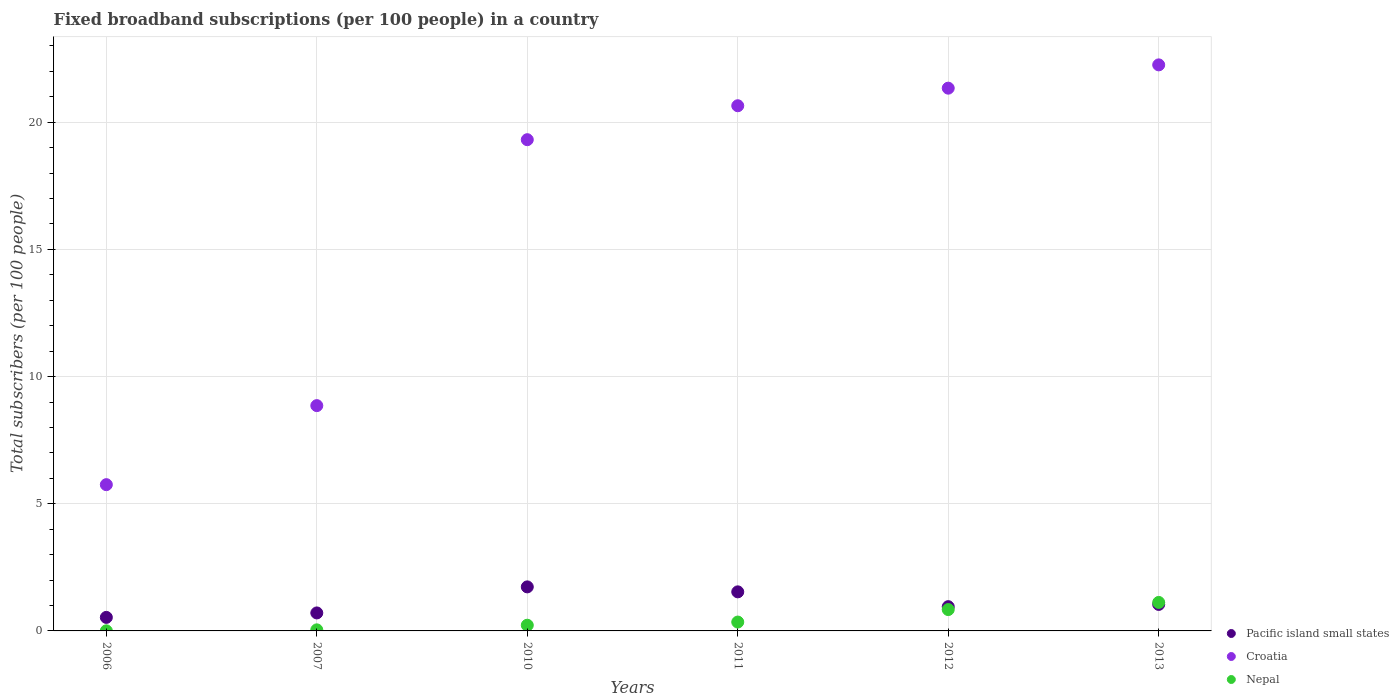How many different coloured dotlines are there?
Keep it short and to the point. 3. Is the number of dotlines equal to the number of legend labels?
Offer a very short reply. Yes. What is the number of broadband subscriptions in Nepal in 2007?
Offer a very short reply. 0.04. Across all years, what is the maximum number of broadband subscriptions in Pacific island small states?
Keep it short and to the point. 1.73. Across all years, what is the minimum number of broadband subscriptions in Nepal?
Your answer should be very brief. 0. In which year was the number of broadband subscriptions in Nepal minimum?
Ensure brevity in your answer.  2006. What is the total number of broadband subscriptions in Pacific island small states in the graph?
Provide a succinct answer. 6.5. What is the difference between the number of broadband subscriptions in Nepal in 2007 and that in 2011?
Provide a short and direct response. -0.31. What is the difference between the number of broadband subscriptions in Croatia in 2013 and the number of broadband subscriptions in Pacific island small states in 2007?
Give a very brief answer. 21.55. What is the average number of broadband subscriptions in Pacific island small states per year?
Offer a terse response. 1.08. In the year 2011, what is the difference between the number of broadband subscriptions in Pacific island small states and number of broadband subscriptions in Nepal?
Provide a short and direct response. 1.19. In how many years, is the number of broadband subscriptions in Croatia greater than 6?
Make the answer very short. 5. What is the ratio of the number of broadband subscriptions in Croatia in 2007 to that in 2010?
Offer a terse response. 0.46. Is the number of broadband subscriptions in Nepal in 2011 less than that in 2013?
Ensure brevity in your answer.  Yes. Is the difference between the number of broadband subscriptions in Pacific island small states in 2007 and 2011 greater than the difference between the number of broadband subscriptions in Nepal in 2007 and 2011?
Offer a very short reply. No. What is the difference between the highest and the second highest number of broadband subscriptions in Croatia?
Ensure brevity in your answer.  0.92. What is the difference between the highest and the lowest number of broadband subscriptions in Croatia?
Offer a very short reply. 16.51. Is it the case that in every year, the sum of the number of broadband subscriptions in Pacific island small states and number of broadband subscriptions in Nepal  is greater than the number of broadband subscriptions in Croatia?
Your response must be concise. No. Does the number of broadband subscriptions in Nepal monotonically increase over the years?
Your answer should be compact. Yes. Is the number of broadband subscriptions in Pacific island small states strictly less than the number of broadband subscriptions in Croatia over the years?
Your answer should be very brief. Yes. What is the difference between two consecutive major ticks on the Y-axis?
Provide a short and direct response. 5. Are the values on the major ticks of Y-axis written in scientific E-notation?
Offer a terse response. No. Does the graph contain any zero values?
Make the answer very short. No. Where does the legend appear in the graph?
Your answer should be very brief. Bottom right. How many legend labels are there?
Your answer should be compact. 3. How are the legend labels stacked?
Your answer should be compact. Vertical. What is the title of the graph?
Your answer should be very brief. Fixed broadband subscriptions (per 100 people) in a country. What is the label or title of the X-axis?
Provide a succinct answer. Years. What is the label or title of the Y-axis?
Your answer should be very brief. Total subscribers (per 100 people). What is the Total subscribers (per 100 people) of Pacific island small states in 2006?
Offer a very short reply. 0.53. What is the Total subscribers (per 100 people) of Croatia in 2006?
Make the answer very short. 5.75. What is the Total subscribers (per 100 people) of Nepal in 2006?
Keep it short and to the point. 0. What is the Total subscribers (per 100 people) in Pacific island small states in 2007?
Your answer should be compact. 0.71. What is the Total subscribers (per 100 people) in Croatia in 2007?
Keep it short and to the point. 8.86. What is the Total subscribers (per 100 people) in Nepal in 2007?
Your answer should be very brief. 0.04. What is the Total subscribers (per 100 people) of Pacific island small states in 2010?
Offer a very short reply. 1.73. What is the Total subscribers (per 100 people) of Croatia in 2010?
Give a very brief answer. 19.31. What is the Total subscribers (per 100 people) in Nepal in 2010?
Your answer should be compact. 0.22. What is the Total subscribers (per 100 people) in Pacific island small states in 2011?
Give a very brief answer. 1.54. What is the Total subscribers (per 100 people) of Croatia in 2011?
Provide a short and direct response. 20.65. What is the Total subscribers (per 100 people) in Nepal in 2011?
Offer a very short reply. 0.35. What is the Total subscribers (per 100 people) in Pacific island small states in 2012?
Your answer should be very brief. 0.95. What is the Total subscribers (per 100 people) of Croatia in 2012?
Ensure brevity in your answer.  21.34. What is the Total subscribers (per 100 people) of Nepal in 2012?
Provide a short and direct response. 0.84. What is the Total subscribers (per 100 people) in Pacific island small states in 2013?
Ensure brevity in your answer.  1.04. What is the Total subscribers (per 100 people) of Croatia in 2013?
Ensure brevity in your answer.  22.26. What is the Total subscribers (per 100 people) of Nepal in 2013?
Offer a terse response. 1.12. Across all years, what is the maximum Total subscribers (per 100 people) in Pacific island small states?
Provide a succinct answer. 1.73. Across all years, what is the maximum Total subscribers (per 100 people) of Croatia?
Keep it short and to the point. 22.26. Across all years, what is the maximum Total subscribers (per 100 people) of Nepal?
Provide a short and direct response. 1.12. Across all years, what is the minimum Total subscribers (per 100 people) of Pacific island small states?
Ensure brevity in your answer.  0.53. Across all years, what is the minimum Total subscribers (per 100 people) in Croatia?
Offer a very short reply. 5.75. Across all years, what is the minimum Total subscribers (per 100 people) in Nepal?
Make the answer very short. 0. What is the total Total subscribers (per 100 people) of Pacific island small states in the graph?
Keep it short and to the point. 6.5. What is the total Total subscribers (per 100 people) in Croatia in the graph?
Offer a very short reply. 98.17. What is the total Total subscribers (per 100 people) of Nepal in the graph?
Offer a very short reply. 2.58. What is the difference between the Total subscribers (per 100 people) of Pacific island small states in 2006 and that in 2007?
Provide a succinct answer. -0.18. What is the difference between the Total subscribers (per 100 people) of Croatia in 2006 and that in 2007?
Your response must be concise. -3.11. What is the difference between the Total subscribers (per 100 people) in Nepal in 2006 and that in 2007?
Ensure brevity in your answer.  -0.04. What is the difference between the Total subscribers (per 100 people) of Pacific island small states in 2006 and that in 2010?
Offer a terse response. -1.2. What is the difference between the Total subscribers (per 100 people) in Croatia in 2006 and that in 2010?
Provide a short and direct response. -13.56. What is the difference between the Total subscribers (per 100 people) in Nepal in 2006 and that in 2010?
Ensure brevity in your answer.  -0.22. What is the difference between the Total subscribers (per 100 people) of Pacific island small states in 2006 and that in 2011?
Offer a very short reply. -1. What is the difference between the Total subscribers (per 100 people) in Croatia in 2006 and that in 2011?
Provide a short and direct response. -14.9. What is the difference between the Total subscribers (per 100 people) of Nepal in 2006 and that in 2011?
Provide a succinct answer. -0.34. What is the difference between the Total subscribers (per 100 people) of Pacific island small states in 2006 and that in 2012?
Your answer should be compact. -0.42. What is the difference between the Total subscribers (per 100 people) in Croatia in 2006 and that in 2012?
Give a very brief answer. -15.59. What is the difference between the Total subscribers (per 100 people) in Nepal in 2006 and that in 2012?
Your answer should be compact. -0.84. What is the difference between the Total subscribers (per 100 people) of Pacific island small states in 2006 and that in 2013?
Keep it short and to the point. -0.51. What is the difference between the Total subscribers (per 100 people) of Croatia in 2006 and that in 2013?
Offer a very short reply. -16.51. What is the difference between the Total subscribers (per 100 people) in Nepal in 2006 and that in 2013?
Give a very brief answer. -1.12. What is the difference between the Total subscribers (per 100 people) in Pacific island small states in 2007 and that in 2010?
Offer a very short reply. -1.02. What is the difference between the Total subscribers (per 100 people) in Croatia in 2007 and that in 2010?
Your response must be concise. -10.46. What is the difference between the Total subscribers (per 100 people) in Nepal in 2007 and that in 2010?
Offer a terse response. -0.18. What is the difference between the Total subscribers (per 100 people) of Pacific island small states in 2007 and that in 2011?
Make the answer very short. -0.83. What is the difference between the Total subscribers (per 100 people) in Croatia in 2007 and that in 2011?
Make the answer very short. -11.79. What is the difference between the Total subscribers (per 100 people) of Nepal in 2007 and that in 2011?
Your answer should be very brief. -0.31. What is the difference between the Total subscribers (per 100 people) of Pacific island small states in 2007 and that in 2012?
Keep it short and to the point. -0.25. What is the difference between the Total subscribers (per 100 people) of Croatia in 2007 and that in 2012?
Provide a short and direct response. -12.48. What is the difference between the Total subscribers (per 100 people) in Nepal in 2007 and that in 2012?
Offer a very short reply. -0.8. What is the difference between the Total subscribers (per 100 people) of Pacific island small states in 2007 and that in 2013?
Keep it short and to the point. -0.33. What is the difference between the Total subscribers (per 100 people) of Croatia in 2007 and that in 2013?
Your answer should be compact. -13.4. What is the difference between the Total subscribers (per 100 people) in Nepal in 2007 and that in 2013?
Make the answer very short. -1.08. What is the difference between the Total subscribers (per 100 people) in Pacific island small states in 2010 and that in 2011?
Your answer should be very brief. 0.2. What is the difference between the Total subscribers (per 100 people) in Croatia in 2010 and that in 2011?
Keep it short and to the point. -1.33. What is the difference between the Total subscribers (per 100 people) of Nepal in 2010 and that in 2011?
Provide a succinct answer. -0.12. What is the difference between the Total subscribers (per 100 people) of Pacific island small states in 2010 and that in 2012?
Your answer should be compact. 0.78. What is the difference between the Total subscribers (per 100 people) of Croatia in 2010 and that in 2012?
Offer a terse response. -2.03. What is the difference between the Total subscribers (per 100 people) in Nepal in 2010 and that in 2012?
Offer a terse response. -0.62. What is the difference between the Total subscribers (per 100 people) of Pacific island small states in 2010 and that in 2013?
Your response must be concise. 0.69. What is the difference between the Total subscribers (per 100 people) of Croatia in 2010 and that in 2013?
Your response must be concise. -2.94. What is the difference between the Total subscribers (per 100 people) in Nepal in 2010 and that in 2013?
Give a very brief answer. -0.9. What is the difference between the Total subscribers (per 100 people) of Pacific island small states in 2011 and that in 2012?
Give a very brief answer. 0.58. What is the difference between the Total subscribers (per 100 people) of Croatia in 2011 and that in 2012?
Your answer should be very brief. -0.69. What is the difference between the Total subscribers (per 100 people) of Nepal in 2011 and that in 2012?
Provide a succinct answer. -0.49. What is the difference between the Total subscribers (per 100 people) of Pacific island small states in 2011 and that in 2013?
Your answer should be very brief. 0.49. What is the difference between the Total subscribers (per 100 people) of Croatia in 2011 and that in 2013?
Offer a very short reply. -1.61. What is the difference between the Total subscribers (per 100 people) in Nepal in 2011 and that in 2013?
Your response must be concise. -0.77. What is the difference between the Total subscribers (per 100 people) of Pacific island small states in 2012 and that in 2013?
Offer a very short reply. -0.09. What is the difference between the Total subscribers (per 100 people) of Croatia in 2012 and that in 2013?
Your answer should be very brief. -0.92. What is the difference between the Total subscribers (per 100 people) in Nepal in 2012 and that in 2013?
Provide a short and direct response. -0.28. What is the difference between the Total subscribers (per 100 people) of Pacific island small states in 2006 and the Total subscribers (per 100 people) of Croatia in 2007?
Your answer should be compact. -8.33. What is the difference between the Total subscribers (per 100 people) of Pacific island small states in 2006 and the Total subscribers (per 100 people) of Nepal in 2007?
Your answer should be very brief. 0.49. What is the difference between the Total subscribers (per 100 people) in Croatia in 2006 and the Total subscribers (per 100 people) in Nepal in 2007?
Ensure brevity in your answer.  5.71. What is the difference between the Total subscribers (per 100 people) in Pacific island small states in 2006 and the Total subscribers (per 100 people) in Croatia in 2010?
Offer a terse response. -18.78. What is the difference between the Total subscribers (per 100 people) of Pacific island small states in 2006 and the Total subscribers (per 100 people) of Nepal in 2010?
Ensure brevity in your answer.  0.31. What is the difference between the Total subscribers (per 100 people) in Croatia in 2006 and the Total subscribers (per 100 people) in Nepal in 2010?
Keep it short and to the point. 5.53. What is the difference between the Total subscribers (per 100 people) in Pacific island small states in 2006 and the Total subscribers (per 100 people) in Croatia in 2011?
Your response must be concise. -20.12. What is the difference between the Total subscribers (per 100 people) of Pacific island small states in 2006 and the Total subscribers (per 100 people) of Nepal in 2011?
Give a very brief answer. 0.18. What is the difference between the Total subscribers (per 100 people) of Croatia in 2006 and the Total subscribers (per 100 people) of Nepal in 2011?
Make the answer very short. 5.4. What is the difference between the Total subscribers (per 100 people) of Pacific island small states in 2006 and the Total subscribers (per 100 people) of Croatia in 2012?
Your answer should be compact. -20.81. What is the difference between the Total subscribers (per 100 people) in Pacific island small states in 2006 and the Total subscribers (per 100 people) in Nepal in 2012?
Offer a terse response. -0.31. What is the difference between the Total subscribers (per 100 people) in Croatia in 2006 and the Total subscribers (per 100 people) in Nepal in 2012?
Offer a very short reply. 4.91. What is the difference between the Total subscribers (per 100 people) of Pacific island small states in 2006 and the Total subscribers (per 100 people) of Croatia in 2013?
Make the answer very short. -21.72. What is the difference between the Total subscribers (per 100 people) in Pacific island small states in 2006 and the Total subscribers (per 100 people) in Nepal in 2013?
Your answer should be compact. -0.59. What is the difference between the Total subscribers (per 100 people) of Croatia in 2006 and the Total subscribers (per 100 people) of Nepal in 2013?
Your response must be concise. 4.63. What is the difference between the Total subscribers (per 100 people) of Pacific island small states in 2007 and the Total subscribers (per 100 people) of Croatia in 2010?
Keep it short and to the point. -18.61. What is the difference between the Total subscribers (per 100 people) of Pacific island small states in 2007 and the Total subscribers (per 100 people) of Nepal in 2010?
Give a very brief answer. 0.48. What is the difference between the Total subscribers (per 100 people) of Croatia in 2007 and the Total subscribers (per 100 people) of Nepal in 2010?
Make the answer very short. 8.63. What is the difference between the Total subscribers (per 100 people) in Pacific island small states in 2007 and the Total subscribers (per 100 people) in Croatia in 2011?
Keep it short and to the point. -19.94. What is the difference between the Total subscribers (per 100 people) of Pacific island small states in 2007 and the Total subscribers (per 100 people) of Nepal in 2011?
Make the answer very short. 0.36. What is the difference between the Total subscribers (per 100 people) of Croatia in 2007 and the Total subscribers (per 100 people) of Nepal in 2011?
Offer a terse response. 8.51. What is the difference between the Total subscribers (per 100 people) of Pacific island small states in 2007 and the Total subscribers (per 100 people) of Croatia in 2012?
Your answer should be very brief. -20.63. What is the difference between the Total subscribers (per 100 people) in Pacific island small states in 2007 and the Total subscribers (per 100 people) in Nepal in 2012?
Your response must be concise. -0.13. What is the difference between the Total subscribers (per 100 people) of Croatia in 2007 and the Total subscribers (per 100 people) of Nepal in 2012?
Offer a very short reply. 8.02. What is the difference between the Total subscribers (per 100 people) of Pacific island small states in 2007 and the Total subscribers (per 100 people) of Croatia in 2013?
Your response must be concise. -21.55. What is the difference between the Total subscribers (per 100 people) of Pacific island small states in 2007 and the Total subscribers (per 100 people) of Nepal in 2013?
Your response must be concise. -0.41. What is the difference between the Total subscribers (per 100 people) in Croatia in 2007 and the Total subscribers (per 100 people) in Nepal in 2013?
Ensure brevity in your answer.  7.74. What is the difference between the Total subscribers (per 100 people) of Pacific island small states in 2010 and the Total subscribers (per 100 people) of Croatia in 2011?
Your answer should be very brief. -18.92. What is the difference between the Total subscribers (per 100 people) in Pacific island small states in 2010 and the Total subscribers (per 100 people) in Nepal in 2011?
Your answer should be very brief. 1.38. What is the difference between the Total subscribers (per 100 people) in Croatia in 2010 and the Total subscribers (per 100 people) in Nepal in 2011?
Your response must be concise. 18.97. What is the difference between the Total subscribers (per 100 people) of Pacific island small states in 2010 and the Total subscribers (per 100 people) of Croatia in 2012?
Keep it short and to the point. -19.61. What is the difference between the Total subscribers (per 100 people) of Pacific island small states in 2010 and the Total subscribers (per 100 people) of Nepal in 2012?
Keep it short and to the point. 0.89. What is the difference between the Total subscribers (per 100 people) of Croatia in 2010 and the Total subscribers (per 100 people) of Nepal in 2012?
Make the answer very short. 18.48. What is the difference between the Total subscribers (per 100 people) of Pacific island small states in 2010 and the Total subscribers (per 100 people) of Croatia in 2013?
Keep it short and to the point. -20.52. What is the difference between the Total subscribers (per 100 people) of Pacific island small states in 2010 and the Total subscribers (per 100 people) of Nepal in 2013?
Your response must be concise. 0.61. What is the difference between the Total subscribers (per 100 people) of Croatia in 2010 and the Total subscribers (per 100 people) of Nepal in 2013?
Provide a succinct answer. 18.19. What is the difference between the Total subscribers (per 100 people) in Pacific island small states in 2011 and the Total subscribers (per 100 people) in Croatia in 2012?
Your response must be concise. -19.8. What is the difference between the Total subscribers (per 100 people) of Pacific island small states in 2011 and the Total subscribers (per 100 people) of Nepal in 2012?
Make the answer very short. 0.7. What is the difference between the Total subscribers (per 100 people) of Croatia in 2011 and the Total subscribers (per 100 people) of Nepal in 2012?
Your response must be concise. 19.81. What is the difference between the Total subscribers (per 100 people) of Pacific island small states in 2011 and the Total subscribers (per 100 people) of Croatia in 2013?
Your response must be concise. -20.72. What is the difference between the Total subscribers (per 100 people) in Pacific island small states in 2011 and the Total subscribers (per 100 people) in Nepal in 2013?
Make the answer very short. 0.42. What is the difference between the Total subscribers (per 100 people) of Croatia in 2011 and the Total subscribers (per 100 people) of Nepal in 2013?
Ensure brevity in your answer.  19.53. What is the difference between the Total subscribers (per 100 people) of Pacific island small states in 2012 and the Total subscribers (per 100 people) of Croatia in 2013?
Provide a succinct answer. -21.3. What is the difference between the Total subscribers (per 100 people) in Pacific island small states in 2012 and the Total subscribers (per 100 people) in Nepal in 2013?
Your response must be concise. -0.17. What is the difference between the Total subscribers (per 100 people) of Croatia in 2012 and the Total subscribers (per 100 people) of Nepal in 2013?
Ensure brevity in your answer.  20.22. What is the average Total subscribers (per 100 people) of Pacific island small states per year?
Give a very brief answer. 1.08. What is the average Total subscribers (per 100 people) in Croatia per year?
Ensure brevity in your answer.  16.36. What is the average Total subscribers (per 100 people) of Nepal per year?
Provide a succinct answer. 0.43. In the year 2006, what is the difference between the Total subscribers (per 100 people) of Pacific island small states and Total subscribers (per 100 people) of Croatia?
Give a very brief answer. -5.22. In the year 2006, what is the difference between the Total subscribers (per 100 people) in Pacific island small states and Total subscribers (per 100 people) in Nepal?
Offer a very short reply. 0.53. In the year 2006, what is the difference between the Total subscribers (per 100 people) in Croatia and Total subscribers (per 100 people) in Nepal?
Provide a short and direct response. 5.75. In the year 2007, what is the difference between the Total subscribers (per 100 people) of Pacific island small states and Total subscribers (per 100 people) of Croatia?
Provide a succinct answer. -8.15. In the year 2007, what is the difference between the Total subscribers (per 100 people) in Pacific island small states and Total subscribers (per 100 people) in Nepal?
Ensure brevity in your answer.  0.67. In the year 2007, what is the difference between the Total subscribers (per 100 people) in Croatia and Total subscribers (per 100 people) in Nepal?
Make the answer very short. 8.82. In the year 2010, what is the difference between the Total subscribers (per 100 people) of Pacific island small states and Total subscribers (per 100 people) of Croatia?
Make the answer very short. -17.58. In the year 2010, what is the difference between the Total subscribers (per 100 people) in Pacific island small states and Total subscribers (per 100 people) in Nepal?
Offer a very short reply. 1.51. In the year 2010, what is the difference between the Total subscribers (per 100 people) in Croatia and Total subscribers (per 100 people) in Nepal?
Offer a very short reply. 19.09. In the year 2011, what is the difference between the Total subscribers (per 100 people) in Pacific island small states and Total subscribers (per 100 people) in Croatia?
Provide a short and direct response. -19.11. In the year 2011, what is the difference between the Total subscribers (per 100 people) in Pacific island small states and Total subscribers (per 100 people) in Nepal?
Ensure brevity in your answer.  1.19. In the year 2011, what is the difference between the Total subscribers (per 100 people) in Croatia and Total subscribers (per 100 people) in Nepal?
Provide a succinct answer. 20.3. In the year 2012, what is the difference between the Total subscribers (per 100 people) in Pacific island small states and Total subscribers (per 100 people) in Croatia?
Provide a succinct answer. -20.39. In the year 2012, what is the difference between the Total subscribers (per 100 people) of Pacific island small states and Total subscribers (per 100 people) of Nepal?
Offer a very short reply. 0.11. In the year 2012, what is the difference between the Total subscribers (per 100 people) of Croatia and Total subscribers (per 100 people) of Nepal?
Keep it short and to the point. 20.5. In the year 2013, what is the difference between the Total subscribers (per 100 people) in Pacific island small states and Total subscribers (per 100 people) in Croatia?
Provide a succinct answer. -21.21. In the year 2013, what is the difference between the Total subscribers (per 100 people) in Pacific island small states and Total subscribers (per 100 people) in Nepal?
Ensure brevity in your answer.  -0.08. In the year 2013, what is the difference between the Total subscribers (per 100 people) in Croatia and Total subscribers (per 100 people) in Nepal?
Offer a terse response. 21.14. What is the ratio of the Total subscribers (per 100 people) of Pacific island small states in 2006 to that in 2007?
Provide a short and direct response. 0.75. What is the ratio of the Total subscribers (per 100 people) in Croatia in 2006 to that in 2007?
Offer a very short reply. 0.65. What is the ratio of the Total subscribers (per 100 people) of Nepal in 2006 to that in 2007?
Offer a very short reply. 0.09. What is the ratio of the Total subscribers (per 100 people) in Pacific island small states in 2006 to that in 2010?
Make the answer very short. 0.31. What is the ratio of the Total subscribers (per 100 people) of Croatia in 2006 to that in 2010?
Offer a terse response. 0.3. What is the ratio of the Total subscribers (per 100 people) of Nepal in 2006 to that in 2010?
Your answer should be very brief. 0.02. What is the ratio of the Total subscribers (per 100 people) of Pacific island small states in 2006 to that in 2011?
Provide a short and direct response. 0.35. What is the ratio of the Total subscribers (per 100 people) of Croatia in 2006 to that in 2011?
Your answer should be compact. 0.28. What is the ratio of the Total subscribers (per 100 people) of Nepal in 2006 to that in 2011?
Provide a short and direct response. 0.01. What is the ratio of the Total subscribers (per 100 people) in Pacific island small states in 2006 to that in 2012?
Give a very brief answer. 0.56. What is the ratio of the Total subscribers (per 100 people) in Croatia in 2006 to that in 2012?
Your answer should be compact. 0.27. What is the ratio of the Total subscribers (per 100 people) in Nepal in 2006 to that in 2012?
Make the answer very short. 0. What is the ratio of the Total subscribers (per 100 people) in Pacific island small states in 2006 to that in 2013?
Keep it short and to the point. 0.51. What is the ratio of the Total subscribers (per 100 people) in Croatia in 2006 to that in 2013?
Your answer should be compact. 0.26. What is the ratio of the Total subscribers (per 100 people) in Nepal in 2006 to that in 2013?
Offer a terse response. 0. What is the ratio of the Total subscribers (per 100 people) of Pacific island small states in 2007 to that in 2010?
Your answer should be compact. 0.41. What is the ratio of the Total subscribers (per 100 people) of Croatia in 2007 to that in 2010?
Your answer should be compact. 0.46. What is the ratio of the Total subscribers (per 100 people) of Nepal in 2007 to that in 2010?
Your response must be concise. 0.19. What is the ratio of the Total subscribers (per 100 people) of Pacific island small states in 2007 to that in 2011?
Give a very brief answer. 0.46. What is the ratio of the Total subscribers (per 100 people) of Croatia in 2007 to that in 2011?
Keep it short and to the point. 0.43. What is the ratio of the Total subscribers (per 100 people) in Nepal in 2007 to that in 2011?
Offer a terse response. 0.12. What is the ratio of the Total subscribers (per 100 people) in Pacific island small states in 2007 to that in 2012?
Your response must be concise. 0.74. What is the ratio of the Total subscribers (per 100 people) in Croatia in 2007 to that in 2012?
Your answer should be very brief. 0.42. What is the ratio of the Total subscribers (per 100 people) of Nepal in 2007 to that in 2012?
Offer a very short reply. 0.05. What is the ratio of the Total subscribers (per 100 people) in Pacific island small states in 2007 to that in 2013?
Offer a very short reply. 0.68. What is the ratio of the Total subscribers (per 100 people) of Croatia in 2007 to that in 2013?
Give a very brief answer. 0.4. What is the ratio of the Total subscribers (per 100 people) in Nepal in 2007 to that in 2013?
Offer a very short reply. 0.04. What is the ratio of the Total subscribers (per 100 people) of Pacific island small states in 2010 to that in 2011?
Provide a short and direct response. 1.13. What is the ratio of the Total subscribers (per 100 people) in Croatia in 2010 to that in 2011?
Your answer should be compact. 0.94. What is the ratio of the Total subscribers (per 100 people) of Nepal in 2010 to that in 2011?
Provide a short and direct response. 0.64. What is the ratio of the Total subscribers (per 100 people) of Pacific island small states in 2010 to that in 2012?
Provide a short and direct response. 1.82. What is the ratio of the Total subscribers (per 100 people) of Croatia in 2010 to that in 2012?
Give a very brief answer. 0.91. What is the ratio of the Total subscribers (per 100 people) in Nepal in 2010 to that in 2012?
Keep it short and to the point. 0.27. What is the ratio of the Total subscribers (per 100 people) in Pacific island small states in 2010 to that in 2013?
Your answer should be very brief. 1.66. What is the ratio of the Total subscribers (per 100 people) of Croatia in 2010 to that in 2013?
Your answer should be very brief. 0.87. What is the ratio of the Total subscribers (per 100 people) of Nepal in 2010 to that in 2013?
Offer a terse response. 0.2. What is the ratio of the Total subscribers (per 100 people) in Pacific island small states in 2011 to that in 2012?
Make the answer very short. 1.61. What is the ratio of the Total subscribers (per 100 people) of Croatia in 2011 to that in 2012?
Offer a terse response. 0.97. What is the ratio of the Total subscribers (per 100 people) of Nepal in 2011 to that in 2012?
Provide a succinct answer. 0.42. What is the ratio of the Total subscribers (per 100 people) of Pacific island small states in 2011 to that in 2013?
Keep it short and to the point. 1.47. What is the ratio of the Total subscribers (per 100 people) of Croatia in 2011 to that in 2013?
Provide a succinct answer. 0.93. What is the ratio of the Total subscribers (per 100 people) of Nepal in 2011 to that in 2013?
Offer a very short reply. 0.31. What is the ratio of the Total subscribers (per 100 people) in Pacific island small states in 2012 to that in 2013?
Make the answer very short. 0.92. What is the ratio of the Total subscribers (per 100 people) in Croatia in 2012 to that in 2013?
Offer a terse response. 0.96. What is the ratio of the Total subscribers (per 100 people) of Nepal in 2012 to that in 2013?
Provide a succinct answer. 0.75. What is the difference between the highest and the second highest Total subscribers (per 100 people) of Pacific island small states?
Provide a short and direct response. 0.2. What is the difference between the highest and the second highest Total subscribers (per 100 people) in Croatia?
Your answer should be very brief. 0.92. What is the difference between the highest and the second highest Total subscribers (per 100 people) in Nepal?
Your answer should be very brief. 0.28. What is the difference between the highest and the lowest Total subscribers (per 100 people) of Pacific island small states?
Give a very brief answer. 1.2. What is the difference between the highest and the lowest Total subscribers (per 100 people) in Croatia?
Your response must be concise. 16.51. What is the difference between the highest and the lowest Total subscribers (per 100 people) in Nepal?
Your answer should be compact. 1.12. 